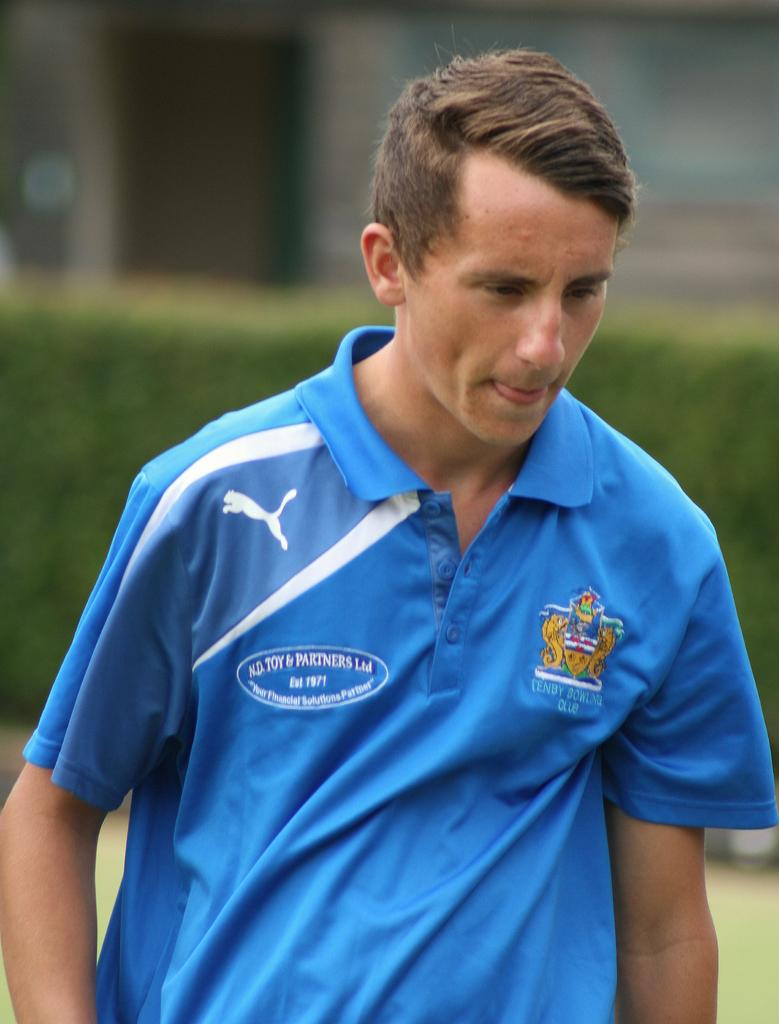What is present in the image? There is a person in the image. What is the person wearing? The person is wearing a T-shirt. What can be seen in the background of the image? There are plants on the grassland in the background of the image. How many feet of sand can be seen in the image? There is no sand present in the image. 